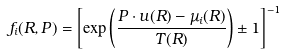Convert formula to latex. <formula><loc_0><loc_0><loc_500><loc_500>f _ { i } ( R , P ) = \left [ \exp \left ( \frac { P \cdot u ( R ) - \mu _ { i } ( R ) } { T ( R ) } \right ) \pm 1 \right ] ^ { - 1 }</formula> 